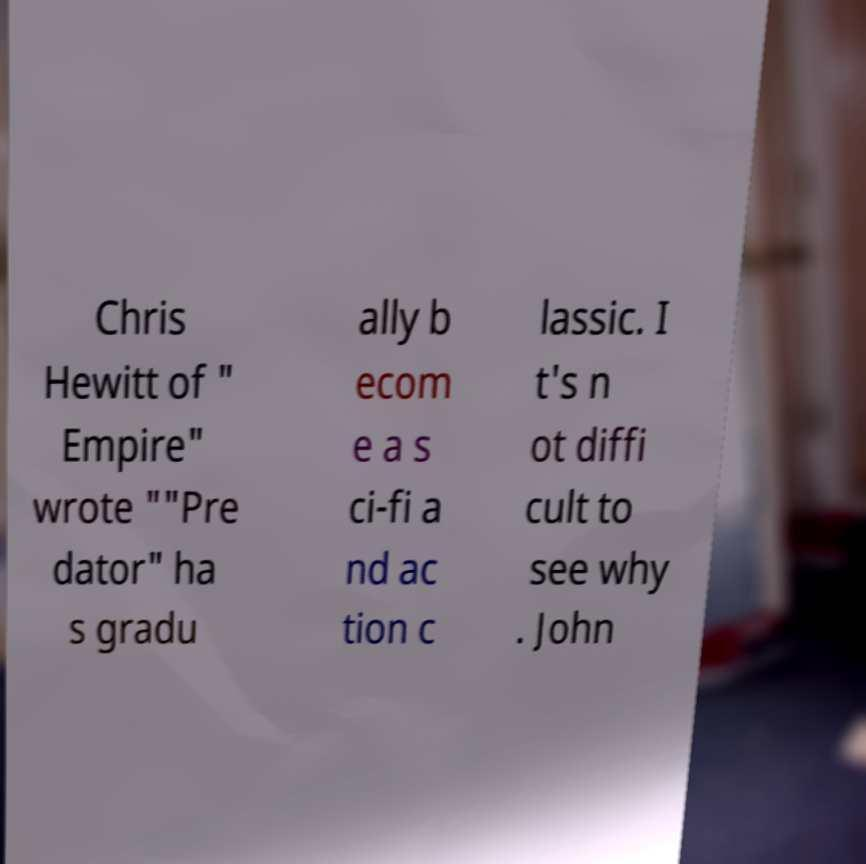Can you accurately transcribe the text from the provided image for me? Chris Hewitt of " Empire" wrote ""Pre dator" ha s gradu ally b ecom e a s ci-fi a nd ac tion c lassic. I t's n ot diffi cult to see why . John 